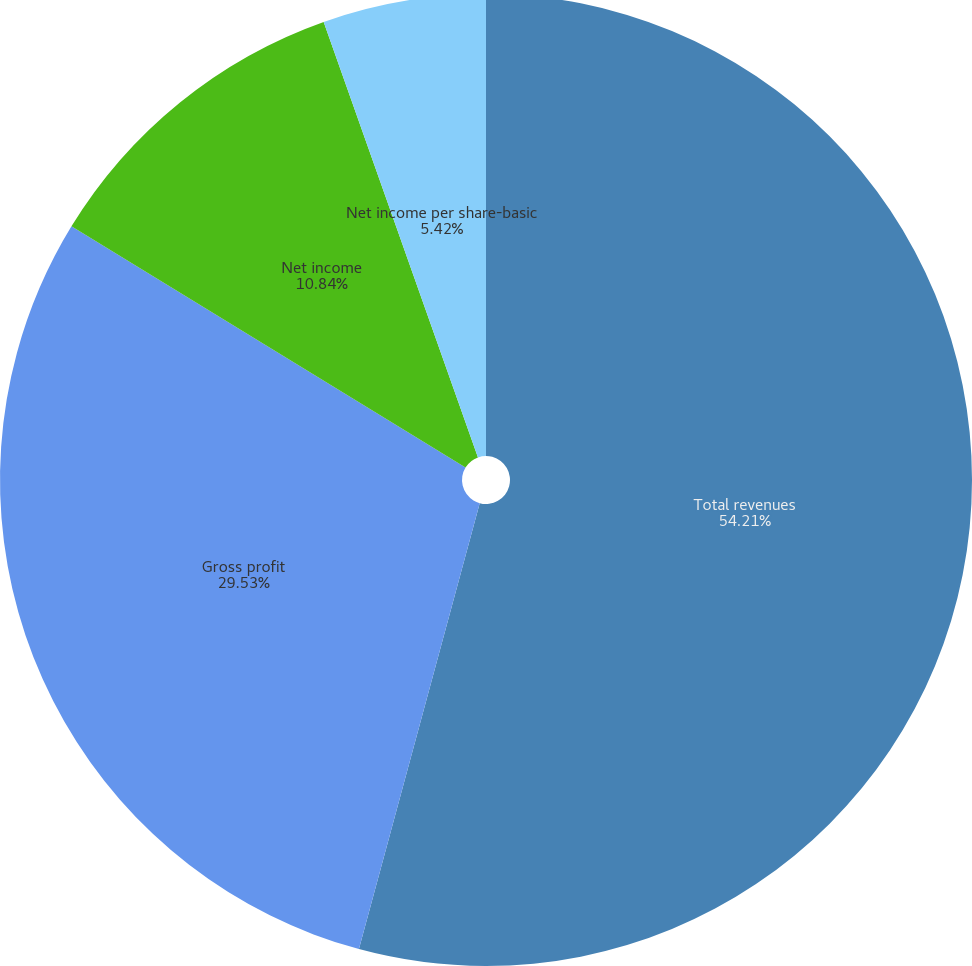<chart> <loc_0><loc_0><loc_500><loc_500><pie_chart><fcel>Total revenues<fcel>Gross profit<fcel>Net income<fcel>Net income per share-basic<fcel>Net income per share-diluted<nl><fcel>54.21%<fcel>29.53%<fcel>10.84%<fcel>5.42%<fcel>0.0%<nl></chart> 